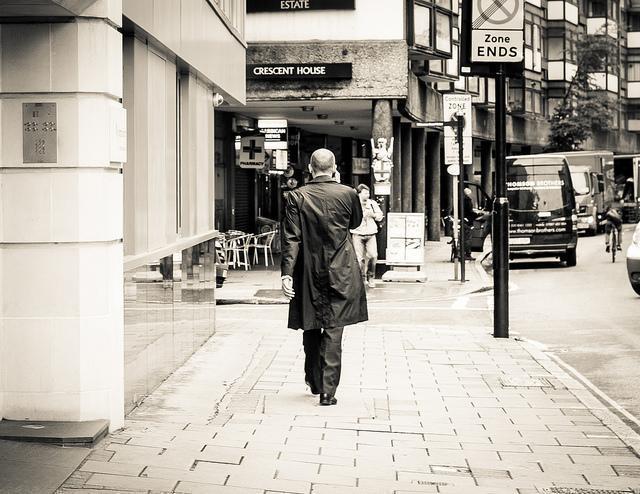During what time of day are the pedestrians walking on this sidewalk?
Make your selection from the four choices given to correctly answer the question.
Options: Evening, morning, night, noon. Morning. 